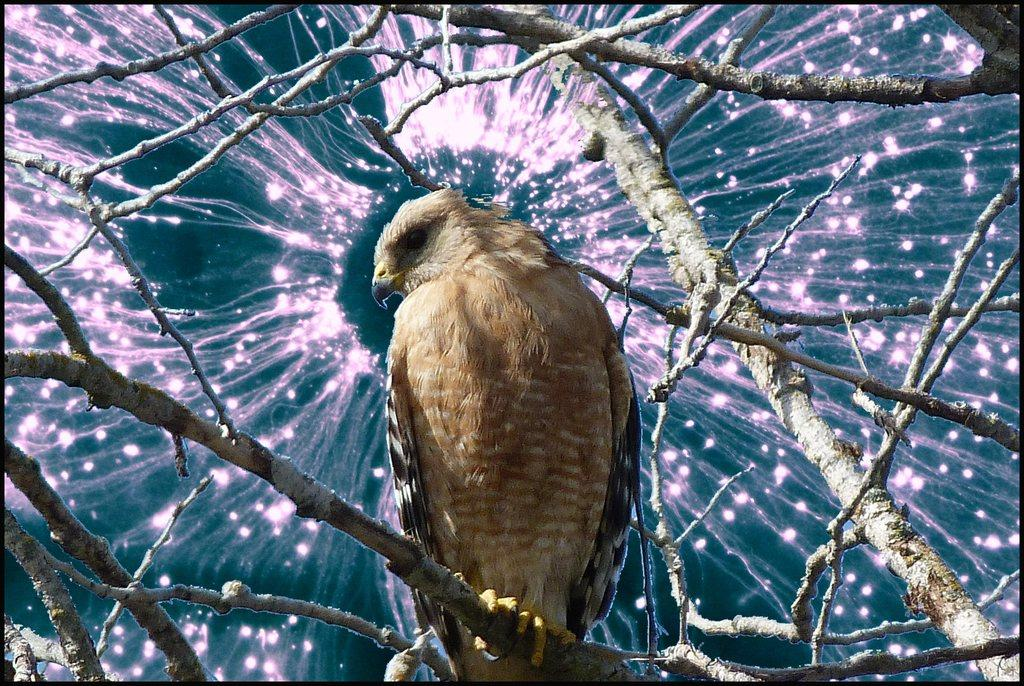What type of animal can be seen in the image? There is a bird in the image. Where is the bird located in the image? The bird is standing on the branch of a tree. What is the rate of the bird's heartbeat in the image? There is no information provided about the bird's heartbeat, so it cannot be determined from the image. 